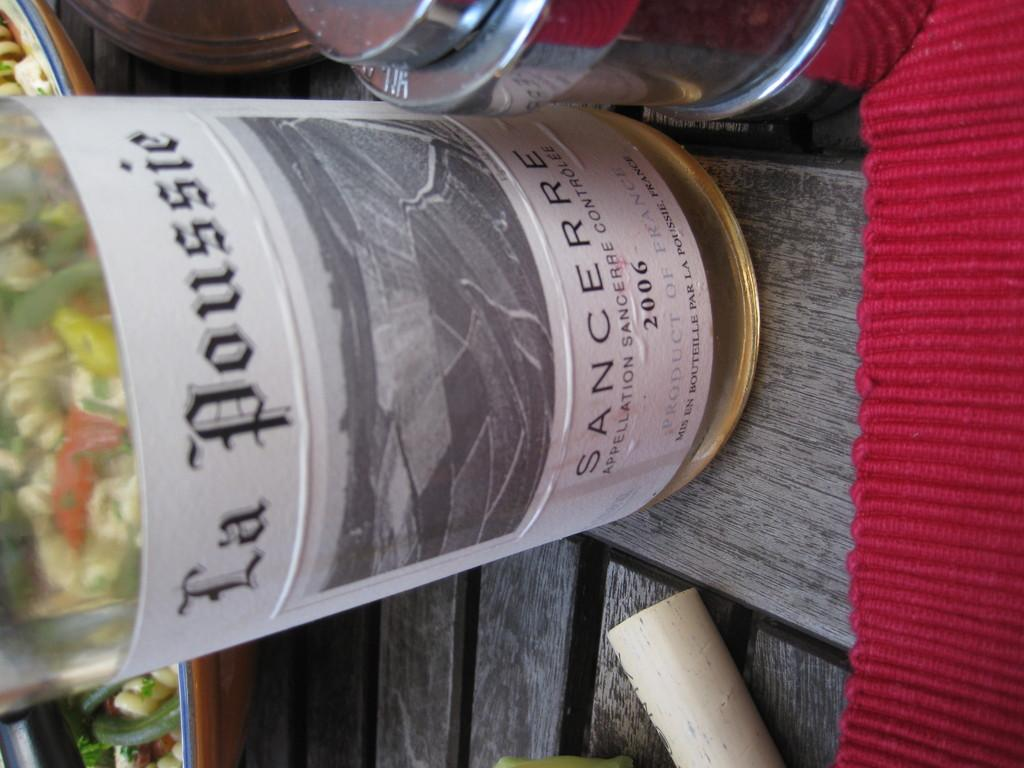<image>
Present a compact description of the photo's key features. a wine bottle that has the year 2006 on it 